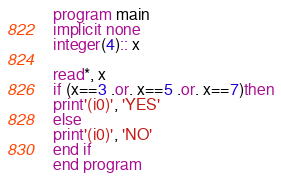<code> <loc_0><loc_0><loc_500><loc_500><_FORTRAN_>program main
implicit none
integer(4):: x

read*, x
if (x==3 .or. x==5 .or. x==7)then
print'(i0)', 'YES'
else
print'(i0)', 'NO'
end if
end program</code> 